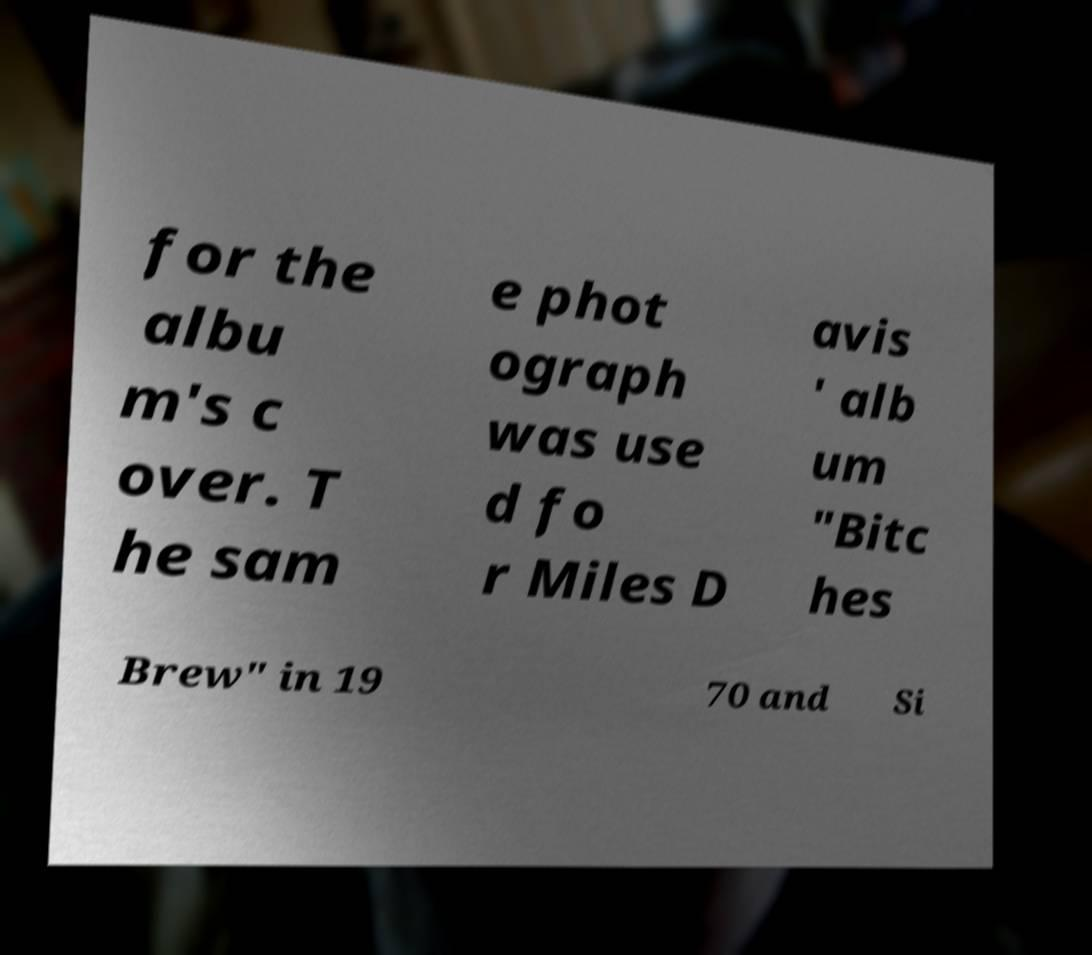Please read and relay the text visible in this image. What does it say? for the albu m's c over. T he sam e phot ograph was use d fo r Miles D avis ' alb um "Bitc hes Brew" in 19 70 and Si 